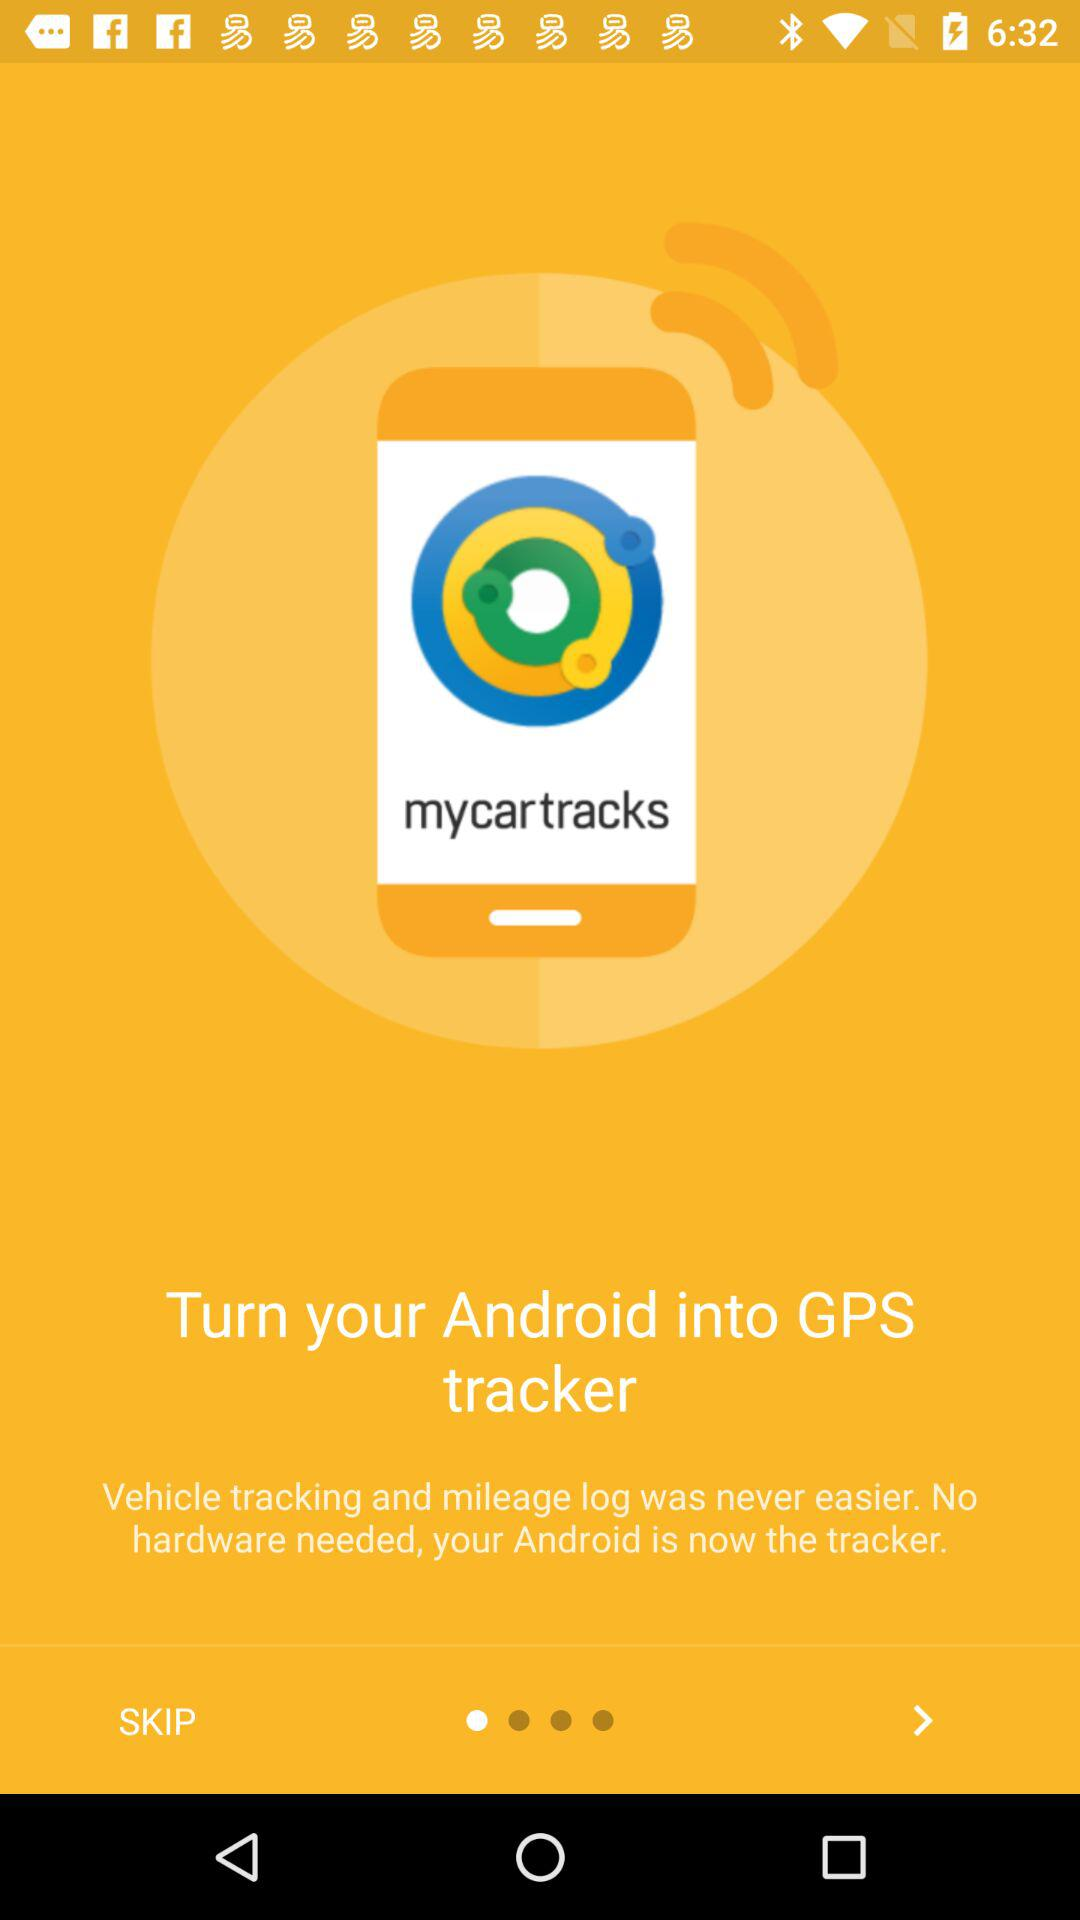What is the name of the application? The application name is "mycartracks". 